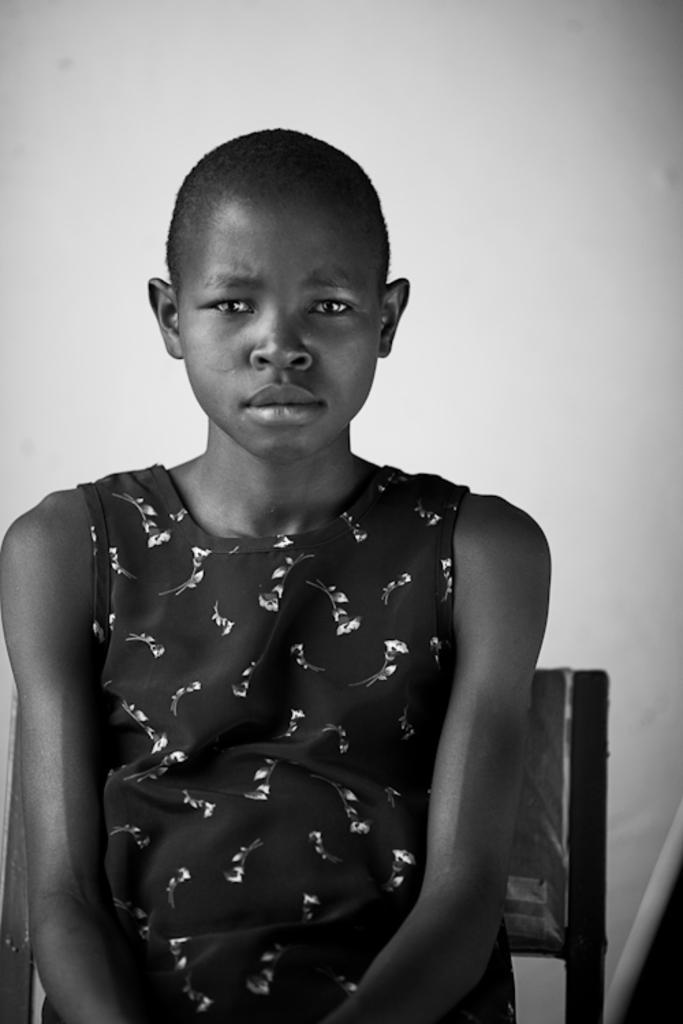Could you give a brief overview of what you see in this image? This is black and white image there is a girl sitting on chair. 